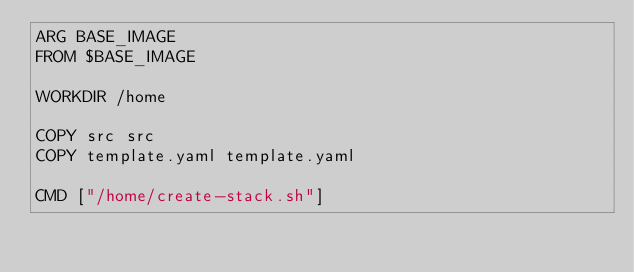Convert code to text. <code><loc_0><loc_0><loc_500><loc_500><_Dockerfile_>ARG BASE_IMAGE
FROM $BASE_IMAGE

WORKDIR /home

COPY src src
COPY template.yaml template.yaml

CMD ["/home/create-stack.sh"]</code> 